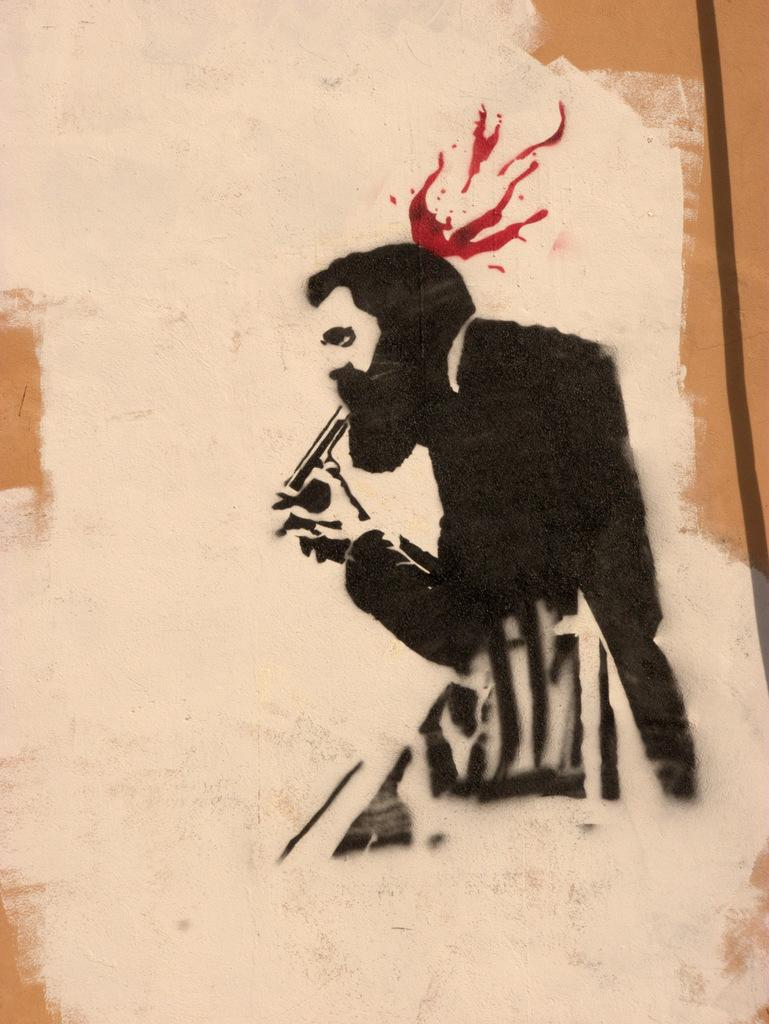What is depicted in the image? There is a sketch of a person in the image. What is the person in the sketch doing? The person is holding an object in the sketch. Where is the sketch located? The sketch is on a board. What type of oatmeal is being served in the sketch? There is no oatmeal present in the image, as it is a sketch of a person holding an object. 